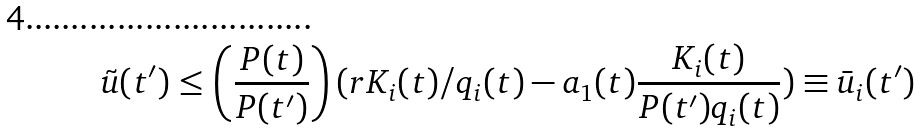<formula> <loc_0><loc_0><loc_500><loc_500>\tilde { u } ( t ^ { \prime } ) \leq \left ( \frac { P ( t ) } { P ( t ^ { \prime } ) } \right ) ( r K _ { i } ( t ) / q _ { i } ( t ) - a _ { 1 } ( t ) \frac { K _ { i } ( t ) } { P ( t ^ { \prime } ) q _ { i } ( t ) } ) \equiv \bar { u } _ { i } ( t ^ { \prime } )</formula> 